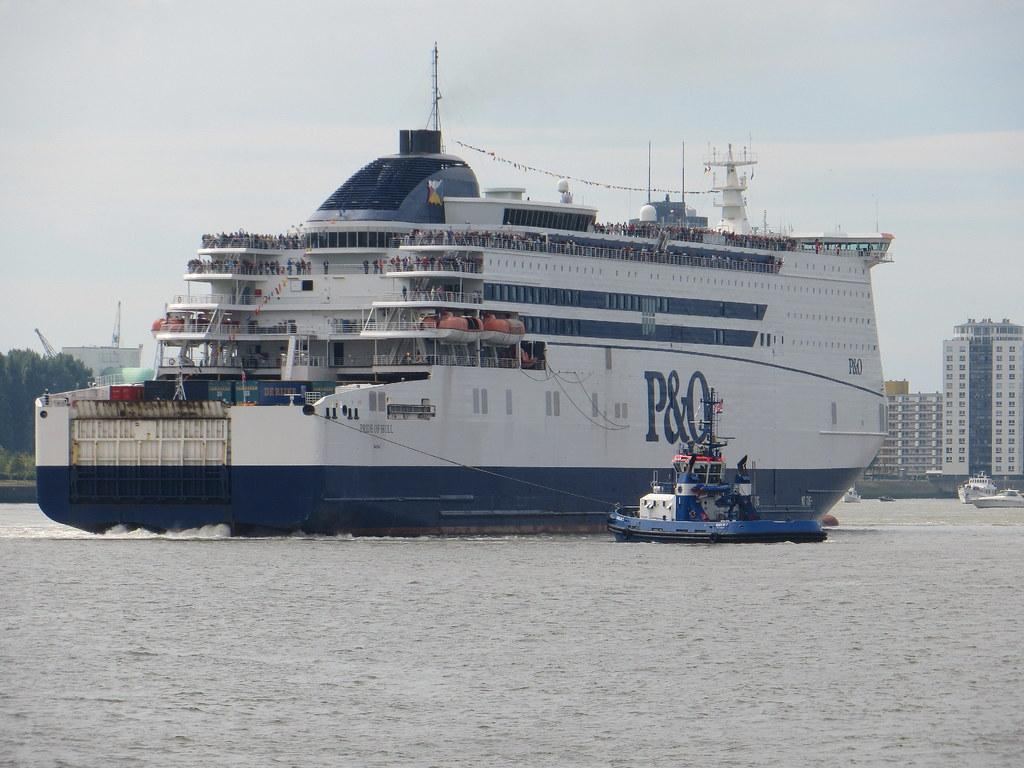<image>
Create a compact narrative representing the image presented. Lare white ship which says P&O on the side. 